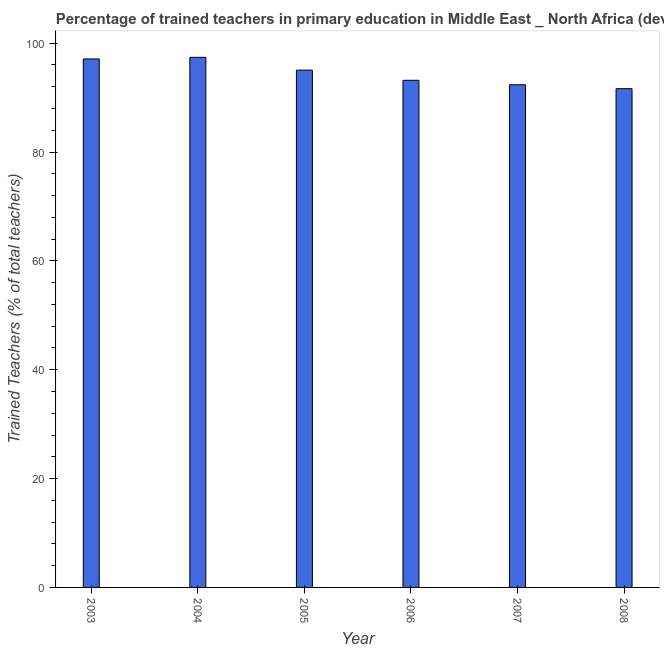What is the title of the graph?
Provide a succinct answer. Percentage of trained teachers in primary education in Middle East _ North Africa (developing only). What is the label or title of the Y-axis?
Offer a terse response. Trained Teachers (% of total teachers). What is the percentage of trained teachers in 2006?
Make the answer very short. 93.18. Across all years, what is the maximum percentage of trained teachers?
Provide a short and direct response. 97.4. Across all years, what is the minimum percentage of trained teachers?
Ensure brevity in your answer.  91.64. In which year was the percentage of trained teachers maximum?
Keep it short and to the point. 2004. What is the sum of the percentage of trained teachers?
Ensure brevity in your answer.  566.71. What is the difference between the percentage of trained teachers in 2007 and 2008?
Provide a short and direct response. 0.72. What is the average percentage of trained teachers per year?
Offer a very short reply. 94.45. What is the median percentage of trained teachers?
Offer a very short reply. 94.11. In how many years, is the percentage of trained teachers greater than 68 %?
Offer a terse response. 6. What is the ratio of the percentage of trained teachers in 2003 to that in 2007?
Keep it short and to the point. 1.05. Is the difference between the percentage of trained teachers in 2006 and 2007 greater than the difference between any two years?
Provide a succinct answer. No. What is the difference between the highest and the second highest percentage of trained teachers?
Provide a succinct answer. 0.3. Is the sum of the percentage of trained teachers in 2004 and 2008 greater than the maximum percentage of trained teachers across all years?
Give a very brief answer. Yes. What is the difference between the highest and the lowest percentage of trained teachers?
Make the answer very short. 5.76. Are all the bars in the graph horizontal?
Ensure brevity in your answer.  No. How many years are there in the graph?
Provide a short and direct response. 6. What is the Trained Teachers (% of total teachers) in 2003?
Your answer should be compact. 97.1. What is the Trained Teachers (% of total teachers) in 2004?
Keep it short and to the point. 97.4. What is the Trained Teachers (% of total teachers) of 2005?
Ensure brevity in your answer.  95.04. What is the Trained Teachers (% of total teachers) in 2006?
Offer a very short reply. 93.18. What is the Trained Teachers (% of total teachers) of 2007?
Keep it short and to the point. 92.36. What is the Trained Teachers (% of total teachers) in 2008?
Provide a short and direct response. 91.64. What is the difference between the Trained Teachers (% of total teachers) in 2003 and 2004?
Provide a short and direct response. -0.3. What is the difference between the Trained Teachers (% of total teachers) in 2003 and 2005?
Make the answer very short. 2.06. What is the difference between the Trained Teachers (% of total teachers) in 2003 and 2006?
Provide a short and direct response. 3.92. What is the difference between the Trained Teachers (% of total teachers) in 2003 and 2007?
Offer a terse response. 4.74. What is the difference between the Trained Teachers (% of total teachers) in 2003 and 2008?
Give a very brief answer. 5.46. What is the difference between the Trained Teachers (% of total teachers) in 2004 and 2005?
Your response must be concise. 2.35. What is the difference between the Trained Teachers (% of total teachers) in 2004 and 2006?
Your response must be concise. 4.22. What is the difference between the Trained Teachers (% of total teachers) in 2004 and 2007?
Provide a short and direct response. 5.04. What is the difference between the Trained Teachers (% of total teachers) in 2004 and 2008?
Ensure brevity in your answer.  5.76. What is the difference between the Trained Teachers (% of total teachers) in 2005 and 2006?
Provide a succinct answer. 1.86. What is the difference between the Trained Teachers (% of total teachers) in 2005 and 2007?
Your answer should be compact. 2.69. What is the difference between the Trained Teachers (% of total teachers) in 2005 and 2008?
Provide a short and direct response. 3.41. What is the difference between the Trained Teachers (% of total teachers) in 2006 and 2007?
Your answer should be very brief. 0.82. What is the difference between the Trained Teachers (% of total teachers) in 2006 and 2008?
Keep it short and to the point. 1.54. What is the difference between the Trained Teachers (% of total teachers) in 2007 and 2008?
Provide a short and direct response. 0.72. What is the ratio of the Trained Teachers (% of total teachers) in 2003 to that in 2006?
Ensure brevity in your answer.  1.04. What is the ratio of the Trained Teachers (% of total teachers) in 2003 to that in 2007?
Provide a succinct answer. 1.05. What is the ratio of the Trained Teachers (% of total teachers) in 2003 to that in 2008?
Ensure brevity in your answer.  1.06. What is the ratio of the Trained Teachers (% of total teachers) in 2004 to that in 2006?
Offer a terse response. 1.04. What is the ratio of the Trained Teachers (% of total teachers) in 2004 to that in 2007?
Provide a succinct answer. 1.05. What is the ratio of the Trained Teachers (% of total teachers) in 2004 to that in 2008?
Your response must be concise. 1.06. What is the ratio of the Trained Teachers (% of total teachers) in 2005 to that in 2006?
Make the answer very short. 1.02. What is the ratio of the Trained Teachers (% of total teachers) in 2005 to that in 2008?
Make the answer very short. 1.04. What is the ratio of the Trained Teachers (% of total teachers) in 2006 to that in 2007?
Provide a succinct answer. 1.01. What is the ratio of the Trained Teachers (% of total teachers) in 2006 to that in 2008?
Give a very brief answer. 1.02. What is the ratio of the Trained Teachers (% of total teachers) in 2007 to that in 2008?
Give a very brief answer. 1.01. 